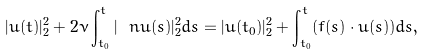Convert formula to latex. <formula><loc_0><loc_0><loc_500><loc_500>| u ( t ) | _ { 2 } ^ { 2 } + 2 \nu \int _ { t _ { 0 } } ^ { t } | \ n u ( s ) | _ { 2 } ^ { 2 } d s = | u ( t _ { 0 } ) | _ { 2 } ^ { 2 } + \int _ { t _ { 0 } } ^ { t } ( f ( s ) \cdot u ( s ) ) d s ,</formula> 